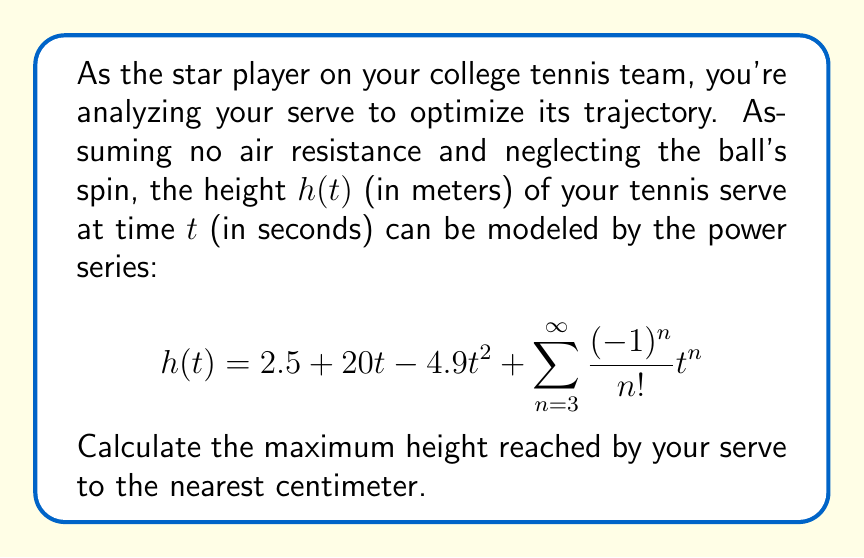What is the answer to this math problem? Let's approach this step-by-step:

1) The maximum height occurs when the velocity is zero, i.e., when $\frac{dh}{dt} = 0$.

2) Let's find $\frac{dh}{dt}$ by differentiating the series term by term:

   $$\frac{dh}{dt} = 20 - 9.8t + \sum_{n=3}^{\infty} \frac{(-1)^n}{(n-1)!}t^{n-1}$$

3) Setting this equal to zero:

   $$20 - 9.8t + \sum_{n=3}^{\infty} \frac{(-1)^n}{(n-1)!}t^{n-1} = 0$$

4) Observe that the sum $\sum_{n=3}^{\infty} \frac{(-1)^n}{(n-1)!}t^{n-1}$ is actually the Taylor series for $-\sin(t)$ minus its first two terms. So our equation becomes:

   $$20 - 9.8t - (\sin(t) - t + \frac{t^2}{2}) = 0$$

5) Simplifying:

   $$20 - 9.8t + t - \frac{t^2}{2} + \sin(t) = 0$$

6) This transcendental equation can't be solved algebraically. However, we can approximate the solution numerically. Using a calculator or computer, we find that $t \approx 2.0408$ seconds.

7) Now, let's substitute this value back into our original height function:

   $$h(2.0408) = 2.5 + 20(2.0408) - 4.9(2.0408)^2 + \sin(2.0408) - 2.0408 + \frac{(2.0408)^2}{2}$$

8) Calculating this (you can use a calculator):

   $$h(2.0408) \approx 22.86 \text{ meters}$$

9) Rounding to the nearest centimeter, we get 22.86 meters.
Answer: 22.86 m 